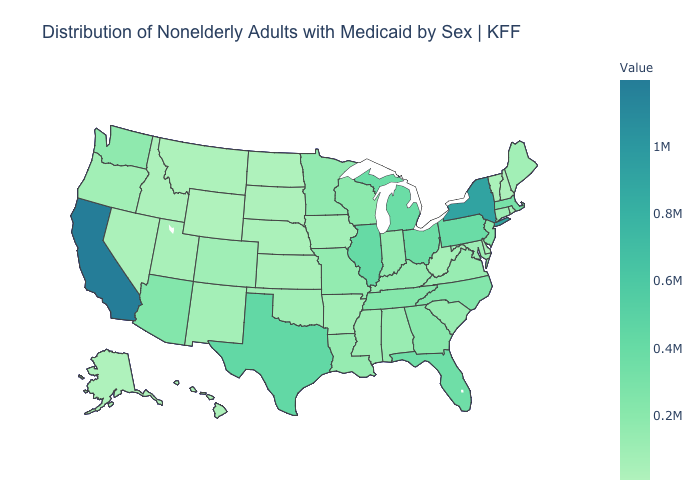Is the legend a continuous bar?
Concise answer only. Yes. Among the states that border Rhode Island , which have the lowest value?
Concise answer only. Connecticut. Does Missouri have a higher value than Nebraska?
Write a very short answer. Yes. Among the states that border Indiana , which have the lowest value?
Give a very brief answer. Kentucky. Among the states that border Illinois , which have the highest value?
Quick response, please. Wisconsin. Does Florida have the highest value in the South?
Keep it brief. No. Which states have the lowest value in the Northeast?
Answer briefly. New Hampshire. Among the states that border Wisconsin , does Illinois have the highest value?
Concise answer only. Yes. 